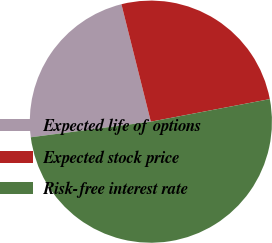Convert chart. <chart><loc_0><loc_0><loc_500><loc_500><pie_chart><fcel>Expected life of options<fcel>Expected stock price<fcel>Risk-free interest rate<nl><fcel>23.15%<fcel>25.93%<fcel>50.93%<nl></chart> 